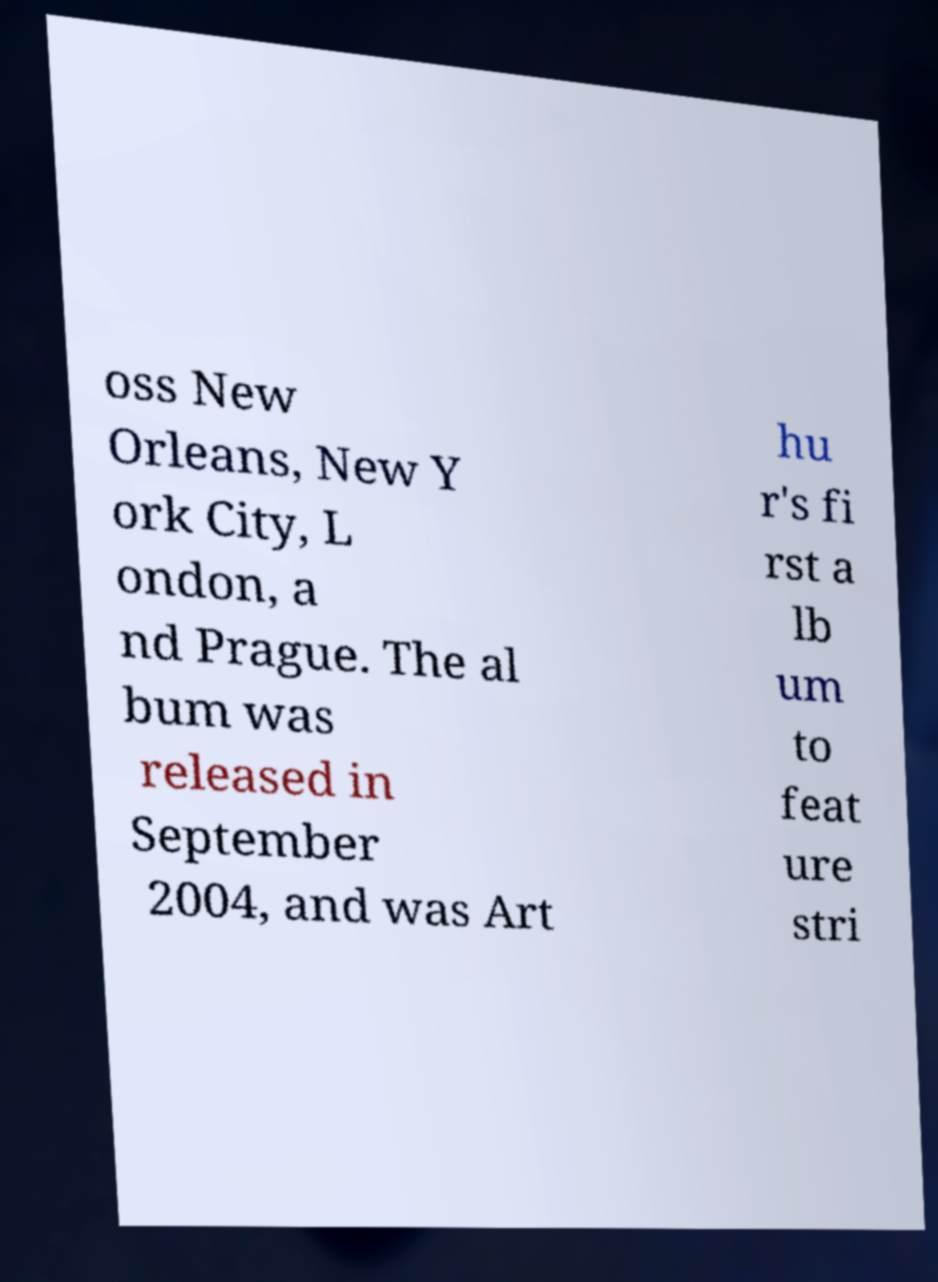Please identify and transcribe the text found in this image. oss New Orleans, New Y ork City, L ondon, a nd Prague. The al bum was released in September 2004, and was Art hu r's fi rst a lb um to feat ure stri 